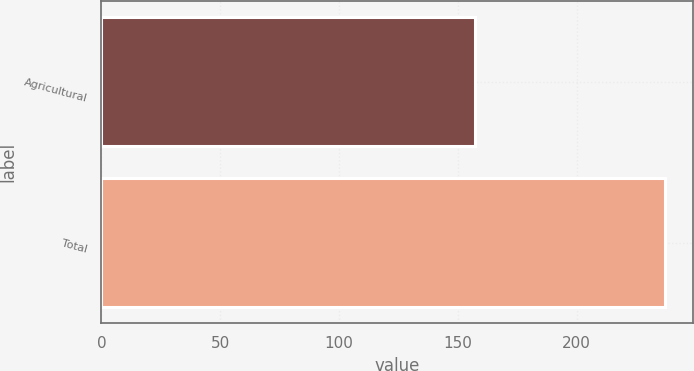<chart> <loc_0><loc_0><loc_500><loc_500><bar_chart><fcel>Agricultural<fcel>Total<nl><fcel>157<fcel>237<nl></chart> 